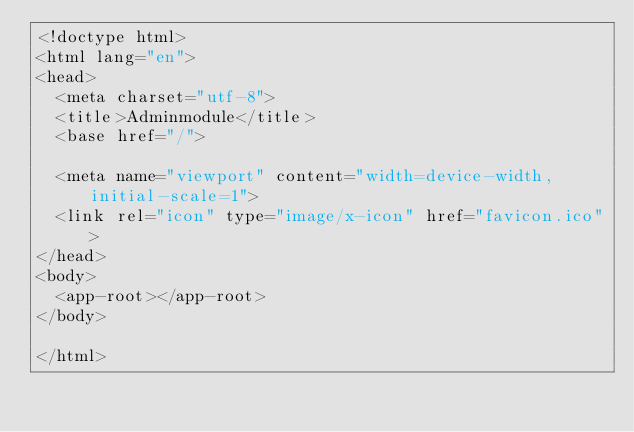<code> <loc_0><loc_0><loc_500><loc_500><_HTML_><!doctype html>
<html lang="en">
<head>
  <meta charset="utf-8">
  <title>Adminmodule</title>
  <base href="/">

  <meta name="viewport" content="width=device-width, initial-scale=1">
  <link rel="icon" type="image/x-icon" href="favicon.ico">
</head>
<body>
  <app-root></app-root>
</body>

</html>
</code> 